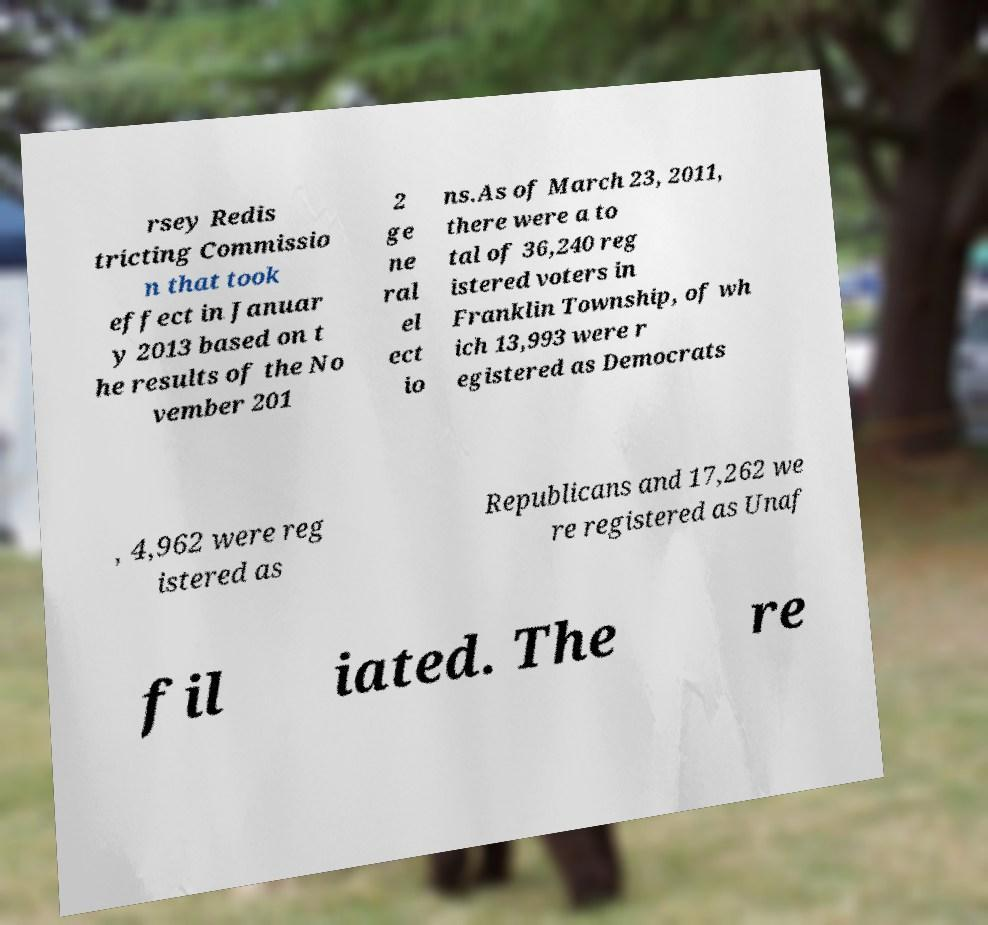I need the written content from this picture converted into text. Can you do that? rsey Redis tricting Commissio n that took effect in Januar y 2013 based on t he results of the No vember 201 2 ge ne ral el ect io ns.As of March 23, 2011, there were a to tal of 36,240 reg istered voters in Franklin Township, of wh ich 13,993 were r egistered as Democrats , 4,962 were reg istered as Republicans and 17,262 we re registered as Unaf fil iated. The re 